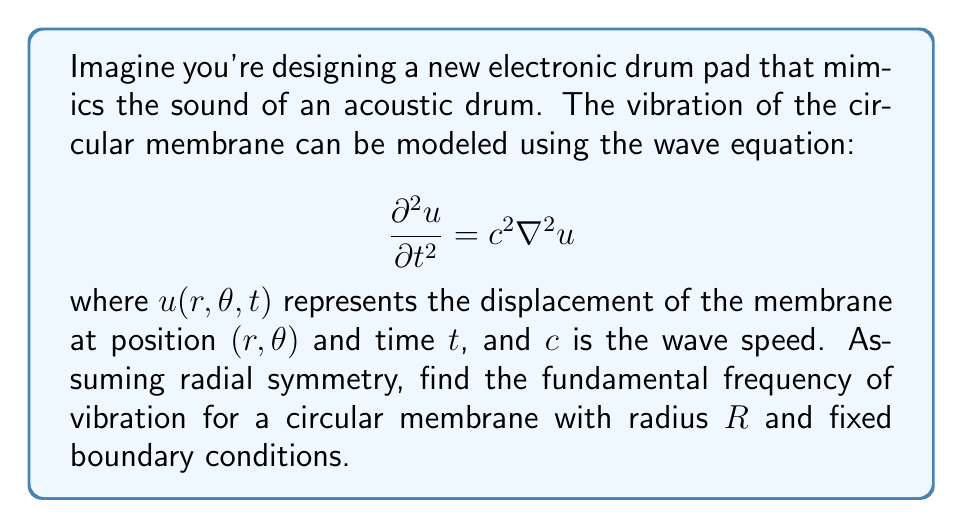Teach me how to tackle this problem. Let's approach this step-by-step:

1) With radial symmetry, the wave equation in polar coordinates reduces to:

   $$\frac{\partial^2 u}{\partial t^2} = c^2 \left(\frac{\partial^2 u}{\partial r^2} + \frac{1}{r}\frac{\partial u}{\partial r}\right)$$

2) We can separate variables: $u(r,t) = R(r)T(t)$

3) This leads to two equations:
   
   $$\frac{d^2T}{dt^2} + \omega^2T = 0$$
   $$\frac{d^2R}{dr^2} + \frac{1}{r}\frac{dR}{dr} + \frac{\omega^2}{c^2}R = 0$$

4) The second equation is Bessel's equation of order zero. Its solution is:

   $$R(r) = AJ_0\left(\frac{\omega r}{c}\right)$$

   where $J_0$ is the Bessel function of the first kind of order zero.

5) The fixed boundary condition means $R(R) = 0$, so:

   $$J_0\left(\frac{\omega R}{c}\right) = 0$$

6) The smallest non-zero solution to this equation is:

   $$\frac{\omega R}{c} \approx 2.4048$$

7) Solving for $\omega$:

   $$\omega \approx \frac{2.4048c}{R}$$

8) The fundamental frequency $f$ is related to $\omega$ by $\omega = 2\pi f$, so:

   $$f \approx \frac{2.4048c}{2\pi R}$$

This is the fundamental frequency of the drum membrane.
Answer: $f \approx \frac{2.4048c}{2\pi R}$ 